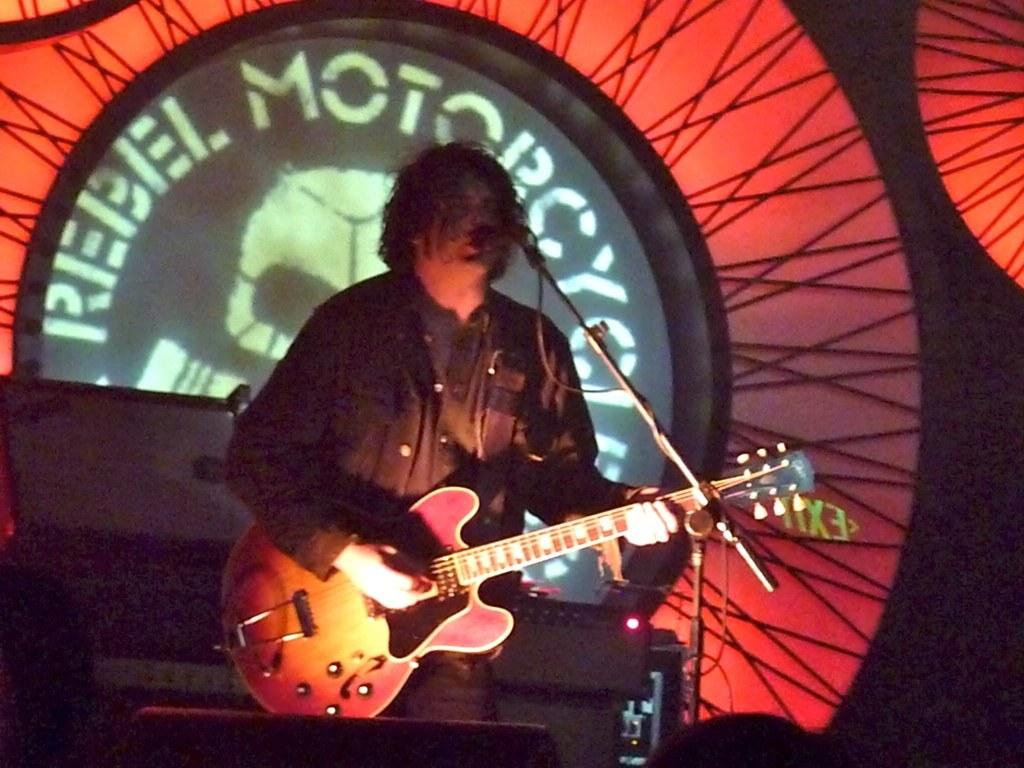What is the man in the image doing? The man is playing a guitar in the image. What object is in front of the man? There is a microphone in front of the man. What is the microphone attached to? The microphone is attached to a microphone stand in the image. What can be seen in the background of the image? There is a light in the background of the image. What type of wind instrument is the man playing in the image? The man is not playing a wind instrument in the image; he is playing a guitar, which is a stringed instrument. 